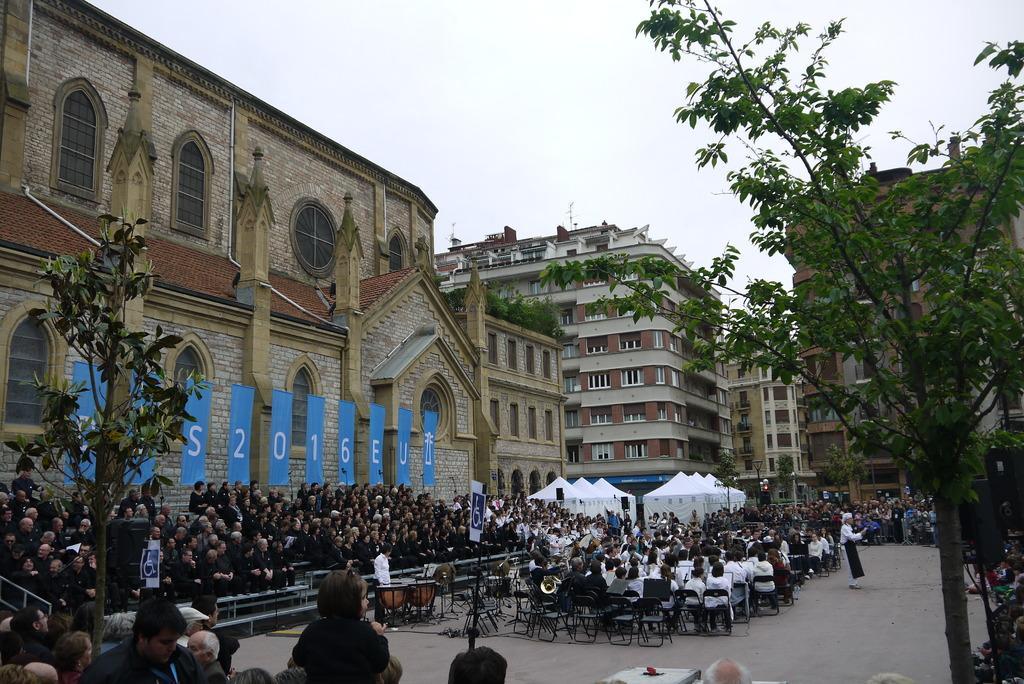In one or two sentences, can you explain what this image depicts? In this image we can see a group of people sitting in the chairs. We can also see a building with windows, plants, trees, road, a person standing and the sky. 